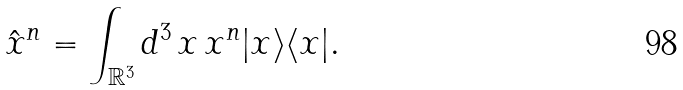Convert formula to latex. <formula><loc_0><loc_0><loc_500><loc_500>\hat { x } ^ { n } = \int _ { \mathbb { R } ^ { 3 } } d ^ { 3 } \, x \, x ^ { n } | x \rangle \langle x | .</formula> 